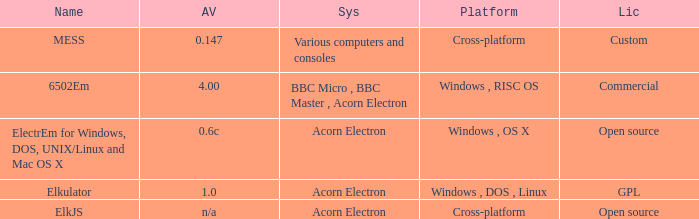What is the system called elkjs? Acorn Electron. 